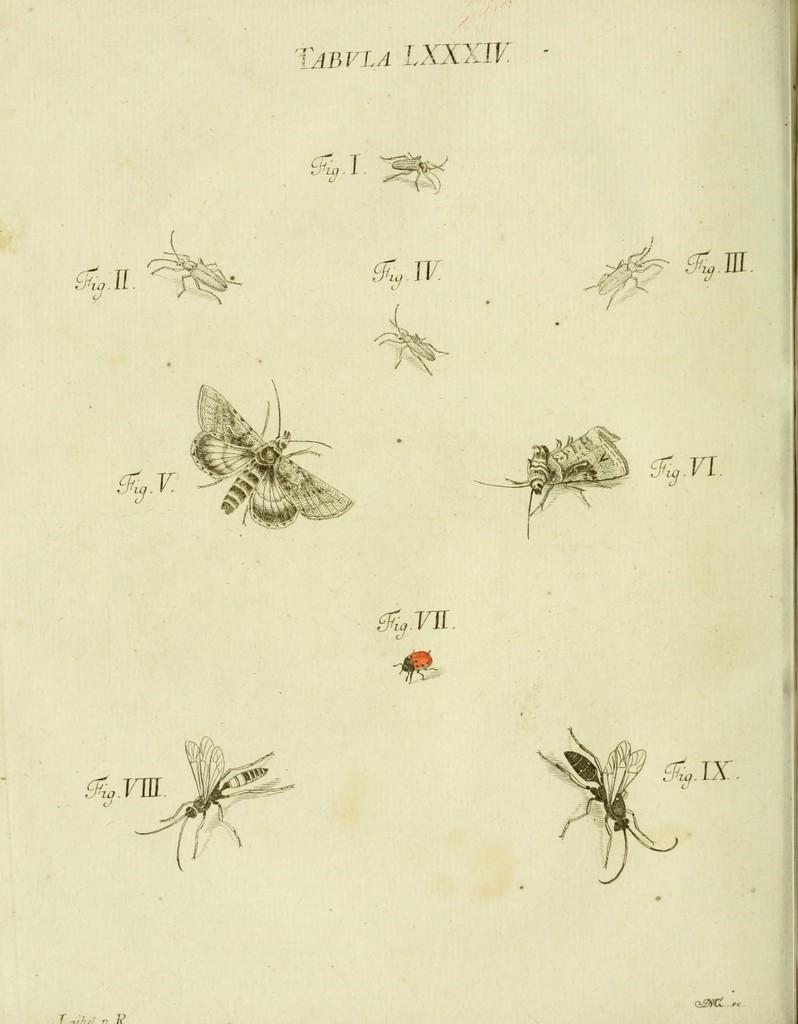What is depicted on the paper in the image? Different types of insects are drawn on the paper. Can you describe the paper in the image? The paper is the main subject in the image, and it has insect drawings on it. What grade did the artist receive for their insect drawings on the paper? There is no indication of a grade or evaluation in the image, as it only shows the paper with insect drawings. 